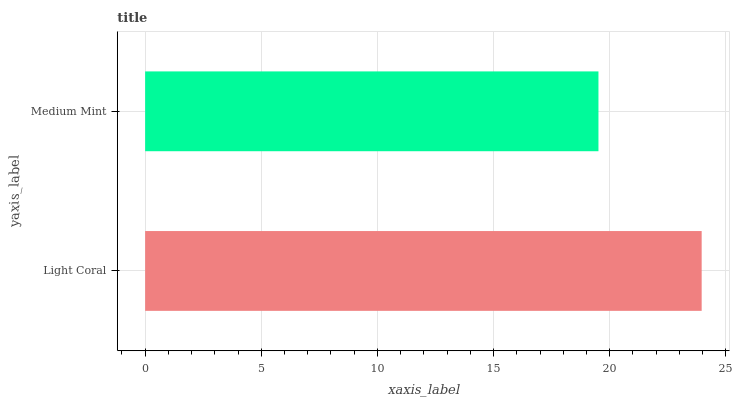Is Medium Mint the minimum?
Answer yes or no. Yes. Is Light Coral the maximum?
Answer yes or no. Yes. Is Medium Mint the maximum?
Answer yes or no. No. Is Light Coral greater than Medium Mint?
Answer yes or no. Yes. Is Medium Mint less than Light Coral?
Answer yes or no. Yes. Is Medium Mint greater than Light Coral?
Answer yes or no. No. Is Light Coral less than Medium Mint?
Answer yes or no. No. Is Light Coral the high median?
Answer yes or no. Yes. Is Medium Mint the low median?
Answer yes or no. Yes. Is Medium Mint the high median?
Answer yes or no. No. Is Light Coral the low median?
Answer yes or no. No. 